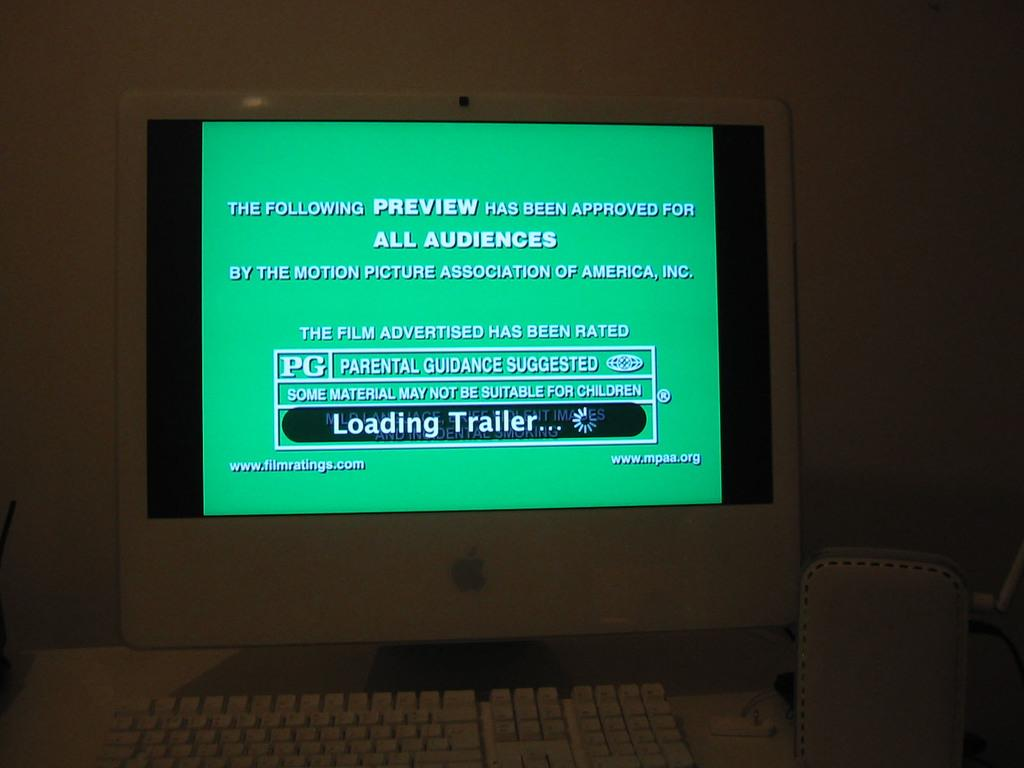Provide a one-sentence caption for the provided image. a computer monitor with a green screen and the words "Loading Trailer.." on it. 